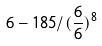<formula> <loc_0><loc_0><loc_500><loc_500>6 - 1 8 5 / ( \frac { 6 } { 6 } ) ^ { 8 }</formula> 